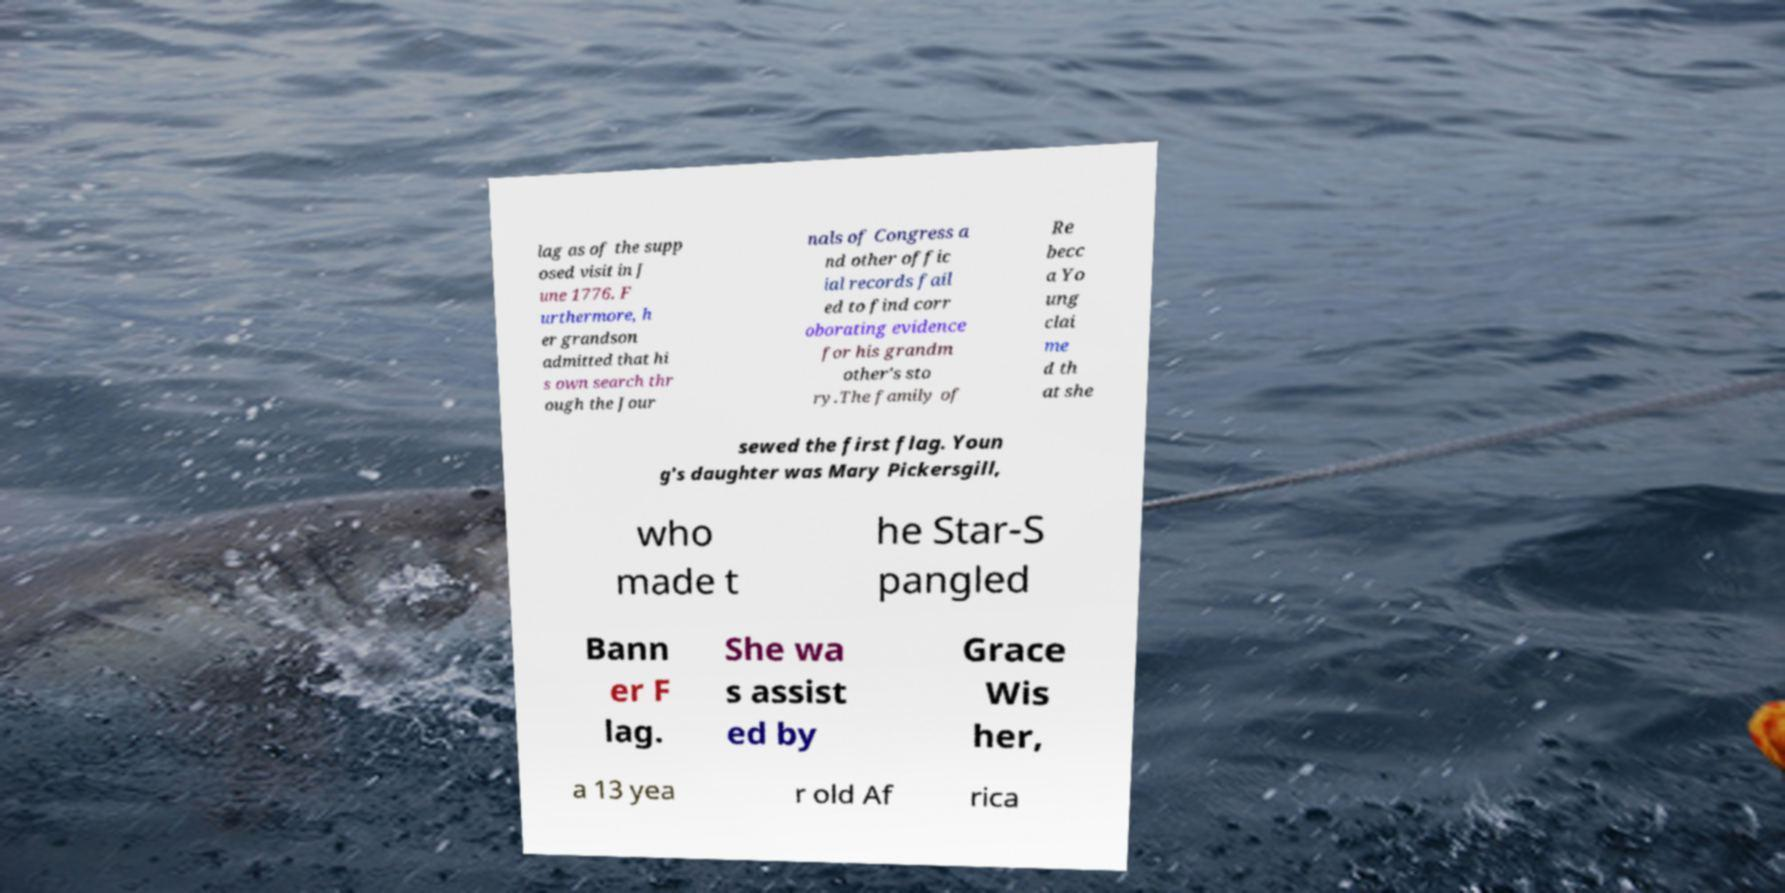I need the written content from this picture converted into text. Can you do that? lag as of the supp osed visit in J une 1776. F urthermore, h er grandson admitted that hi s own search thr ough the Jour nals of Congress a nd other offic ial records fail ed to find corr oborating evidence for his grandm other's sto ry.The family of Re becc a Yo ung clai me d th at she sewed the first flag. Youn g's daughter was Mary Pickersgill, who made t he Star-S pangled Bann er F lag. She wa s assist ed by Grace Wis her, a 13 yea r old Af rica 